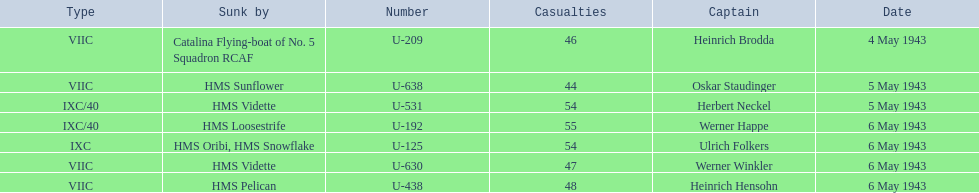What boats were lost on may 5? U-638, U-531. Who were the captains of those boats? Oskar Staudinger, Herbert Neckel. Which captain was not oskar staudinger? Herbert Neckel. 